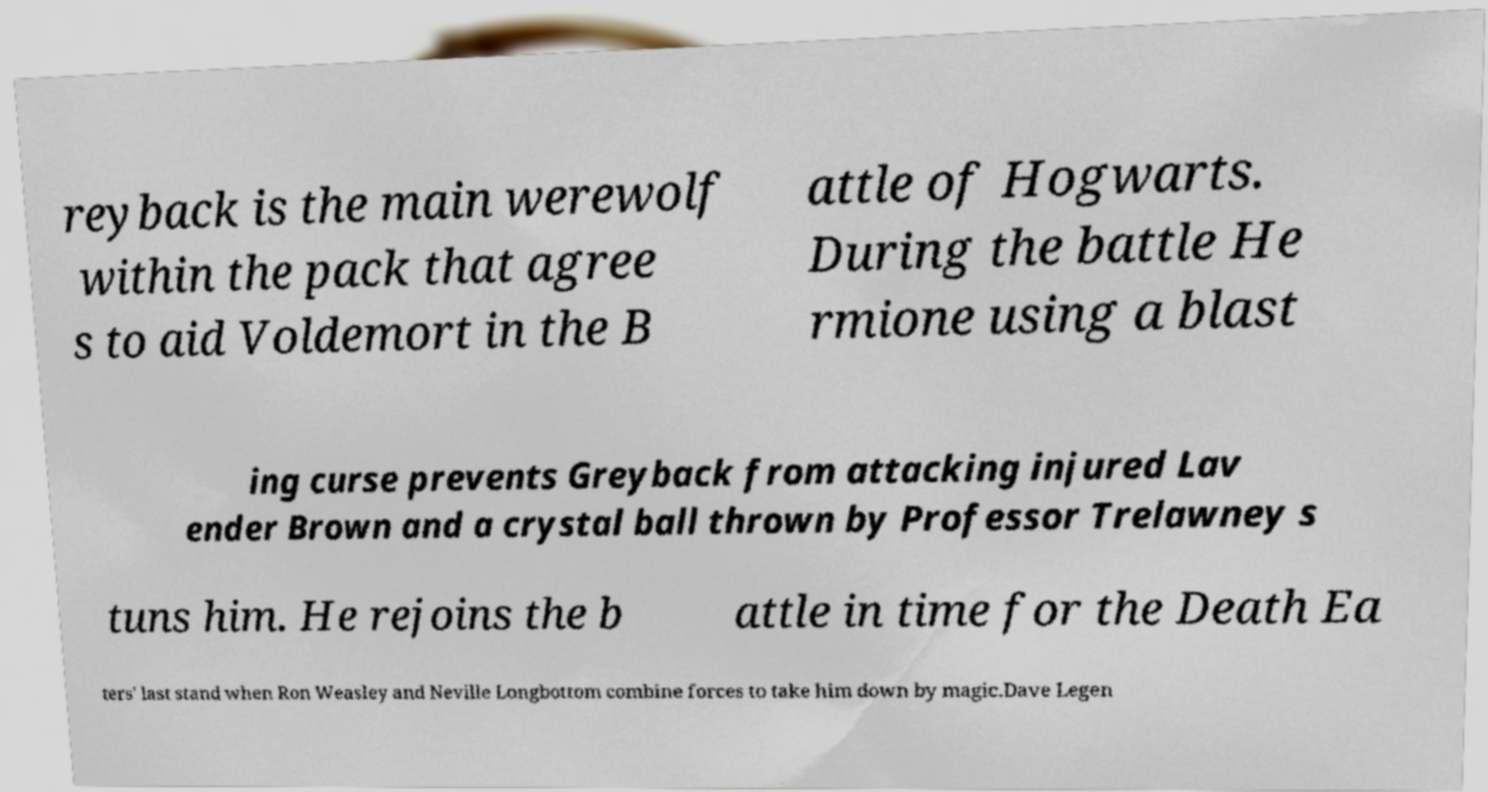Please identify and transcribe the text found in this image. reyback is the main werewolf within the pack that agree s to aid Voldemort in the B attle of Hogwarts. During the battle He rmione using a blast ing curse prevents Greyback from attacking injured Lav ender Brown and a crystal ball thrown by Professor Trelawney s tuns him. He rejoins the b attle in time for the Death Ea ters' last stand when Ron Weasley and Neville Longbottom combine forces to take him down by magic.Dave Legen 